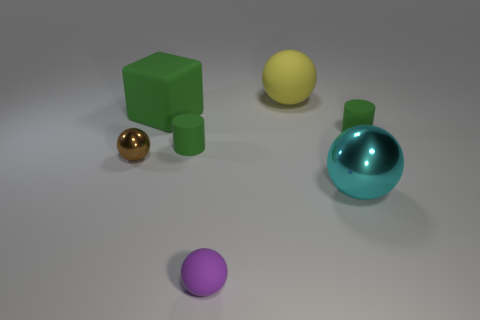Subtract all cyan balls. How many balls are left? 3 Subtract all green spheres. Subtract all cyan blocks. How many spheres are left? 4 Add 3 small rubber blocks. How many objects exist? 10 Subtract all blocks. How many objects are left? 6 Add 5 big cyan things. How many big cyan things are left? 6 Add 3 big brown rubber balls. How many big brown rubber balls exist? 3 Subtract 0 brown cubes. How many objects are left? 7 Subtract all small rubber objects. Subtract all large cyan balls. How many objects are left? 3 